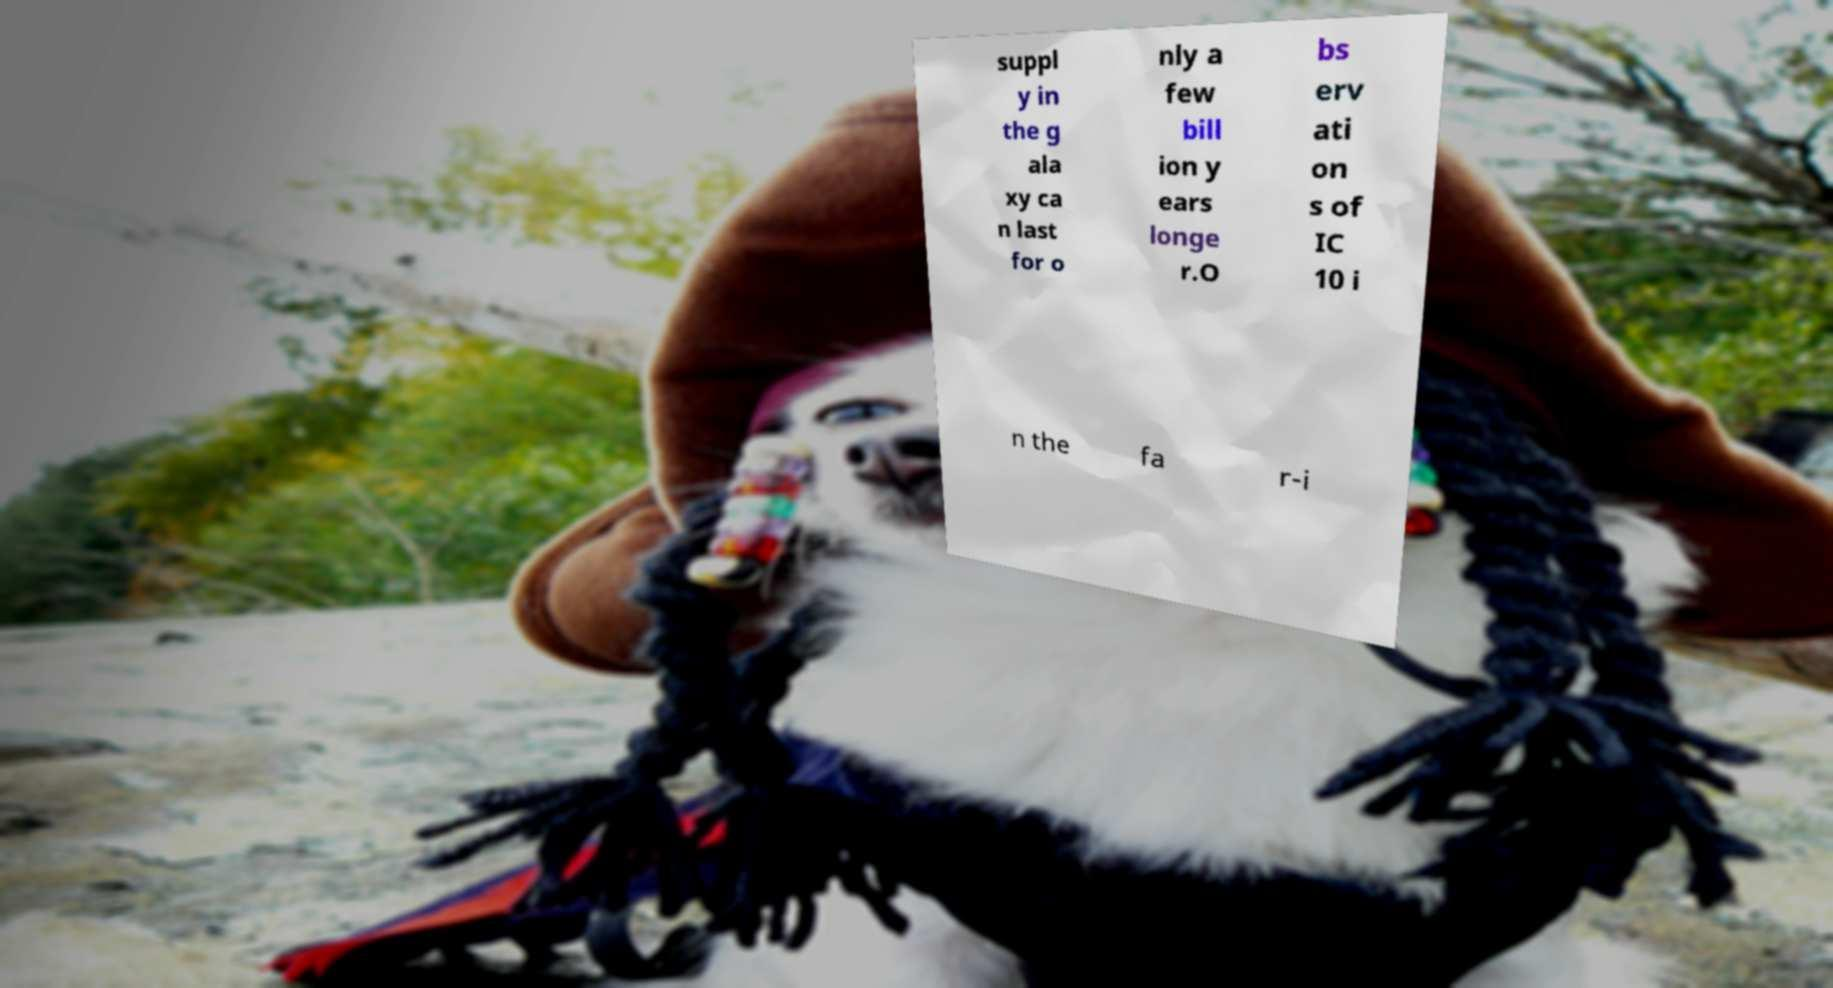Please read and relay the text visible in this image. What does it say? suppl y in the g ala xy ca n last for o nly a few bill ion y ears longe r.O bs erv ati on s of IC 10 i n the fa r-i 